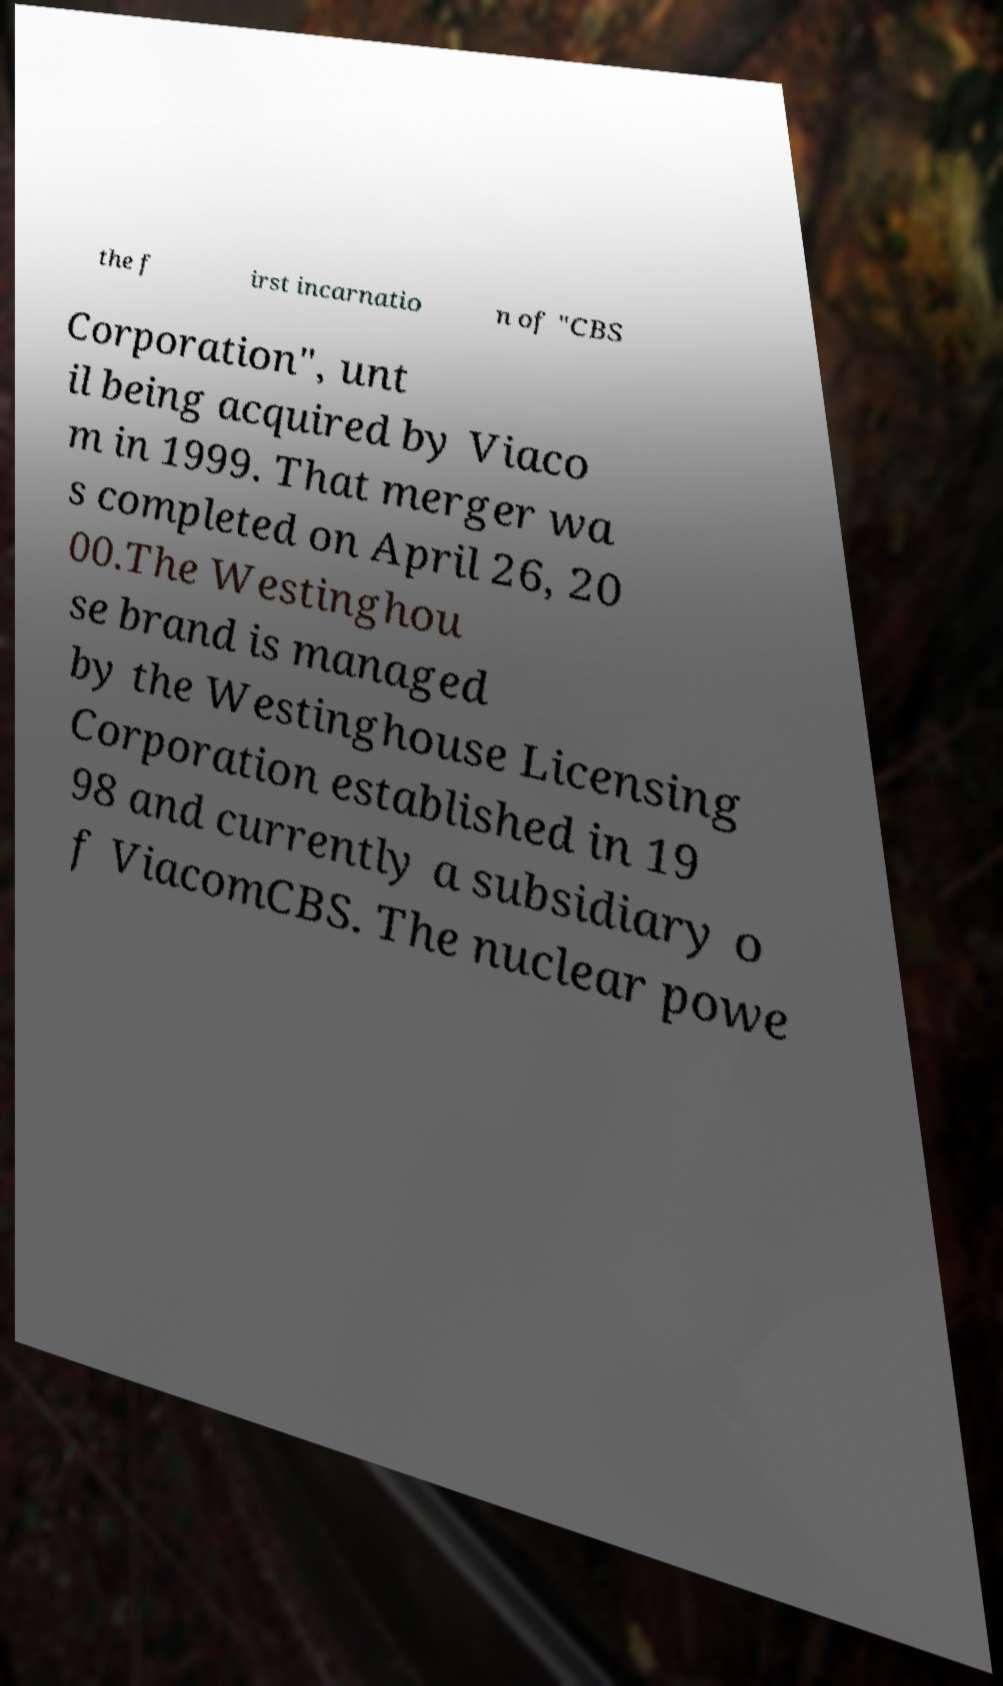I need the written content from this picture converted into text. Can you do that? the f irst incarnatio n of "CBS Corporation", unt il being acquired by Viaco m in 1999. That merger wa s completed on April 26, 20 00.The Westinghou se brand is managed by the Westinghouse Licensing Corporation established in 19 98 and currently a subsidiary o f ViacomCBS. The nuclear powe 